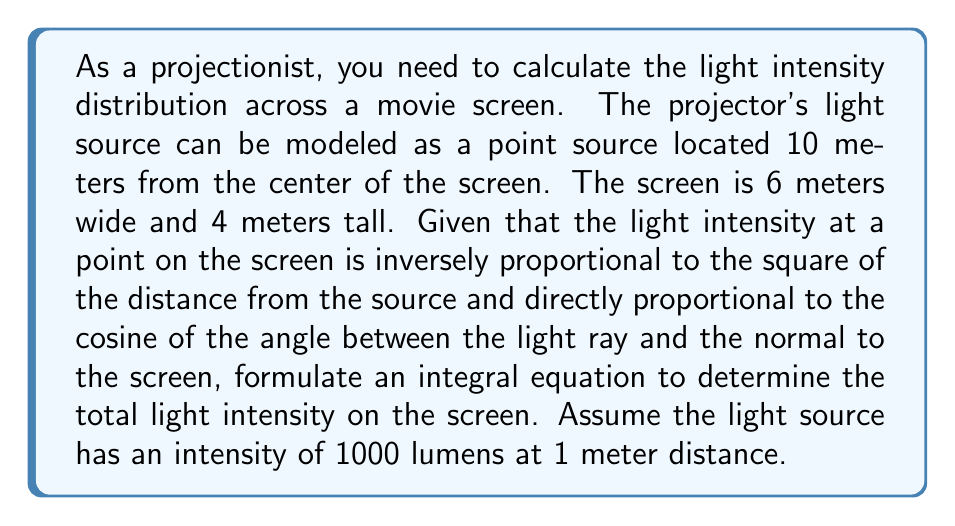Provide a solution to this math problem. Let's approach this step-by-step:

1) First, we need to set up our coordinate system. Let's place the origin at the center of the screen, with the x-axis along the width and the y-axis along the height. The z-axis will be perpendicular to the screen, with the projector at (0, 0, 10).

2) For any point (x, y) on the screen, the distance r from the projector is:

   $$r = \sqrt{x^2 + y^2 + 10^2}$$

3) The cosine of the angle between the light ray and the normal to the screen is:

   $$\cos \theta = \frac{10}{r} = \frac{10}{\sqrt{x^2 + y^2 + 10^2}}$$

4) The intensity at a point (x, y) on the screen, I(x, y), is given by:

   $$I(x,y) = \frac{1000 \cdot \cos \theta}{r^2} = \frac{10000}{(x^2 + y^2 + 100)^{3/2}}$$

5) To find the total light intensity, we need to integrate this function over the entire screen:

   $$\text{Total Intensity} = \int_{-3}^{3} \int_{-2}^{2} \frac{10000}{(x^2 + y^2 + 100)^{3/2}} dy dx$$

6) This double integral represents our integral equation for the total light intensity on the screen.

7) Unfortunately, this integral doesn't have a simple closed-form solution and would typically be evaluated numerically in practice.
Answer: $$\int_{-3}^{3} \int_{-2}^{2} \frac{10000}{(x^2 + y^2 + 100)^{3/2}} dy dx$$ 